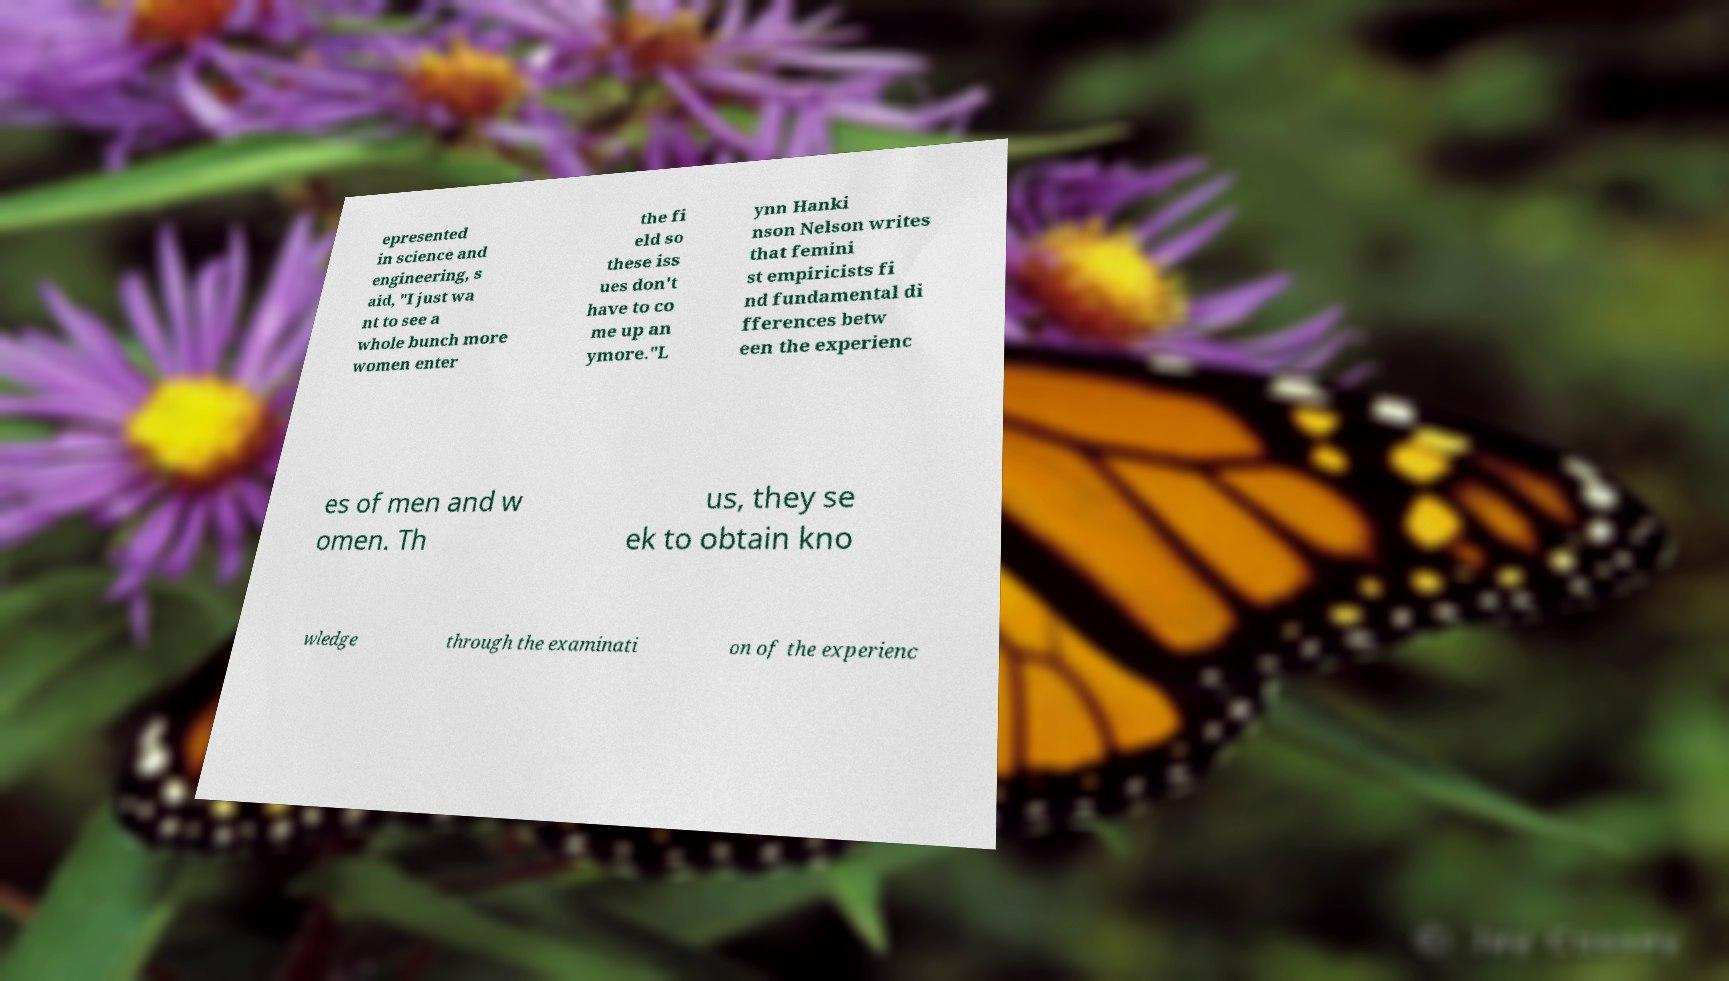Please read and relay the text visible in this image. What does it say? epresented in science and engineering, s aid, "I just wa nt to see a whole bunch more women enter the fi eld so these iss ues don't have to co me up an ymore."L ynn Hanki nson Nelson writes that femini st empiricists fi nd fundamental di fferences betw een the experienc es of men and w omen. Th us, they se ek to obtain kno wledge through the examinati on of the experienc 